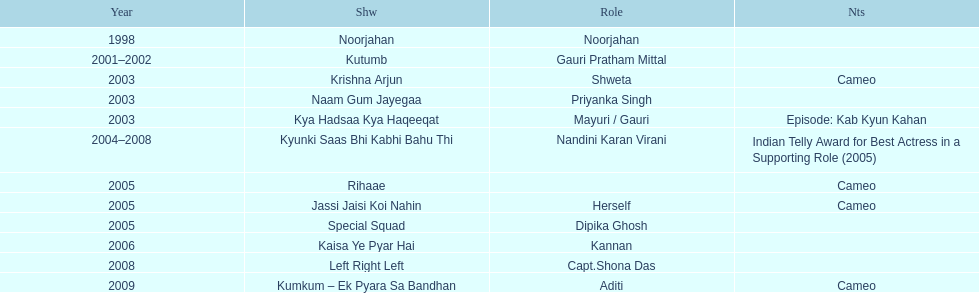Which television show was gauri in for the longest amount of time? Kyunki Saas Bhi Kabhi Bahu Thi. 